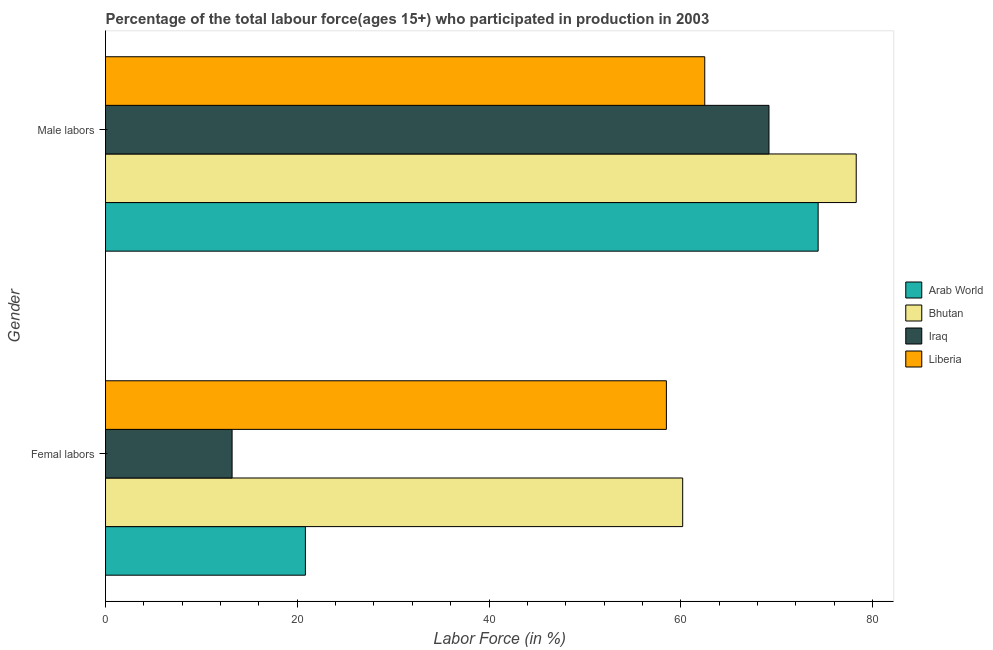How many bars are there on the 1st tick from the top?
Offer a very short reply. 4. What is the label of the 2nd group of bars from the top?
Your response must be concise. Femal labors. What is the percentage of male labour force in Bhutan?
Your response must be concise. 78.3. Across all countries, what is the maximum percentage of female labor force?
Make the answer very short. 60.2. Across all countries, what is the minimum percentage of male labour force?
Provide a succinct answer. 62.5. In which country was the percentage of male labour force maximum?
Provide a short and direct response. Bhutan. In which country was the percentage of male labour force minimum?
Your answer should be very brief. Liberia. What is the total percentage of male labour force in the graph?
Give a very brief answer. 284.33. What is the difference between the percentage of female labor force in Arab World and that in Bhutan?
Ensure brevity in your answer.  -39.35. What is the difference between the percentage of male labour force in Bhutan and the percentage of female labor force in Iraq?
Keep it short and to the point. 65.1. What is the average percentage of female labor force per country?
Your answer should be compact. 38.19. What is the difference between the percentage of female labor force and percentage of male labour force in Arab World?
Provide a succinct answer. -53.48. What is the ratio of the percentage of female labor force in Bhutan to that in Arab World?
Make the answer very short. 2.89. In how many countries, is the percentage of female labor force greater than the average percentage of female labor force taken over all countries?
Offer a very short reply. 2. What does the 2nd bar from the top in Male labors represents?
Your response must be concise. Iraq. What does the 3rd bar from the bottom in Male labors represents?
Your answer should be very brief. Iraq. How many bars are there?
Provide a succinct answer. 8. Are all the bars in the graph horizontal?
Your answer should be compact. Yes. How many countries are there in the graph?
Offer a very short reply. 4. What is the difference between two consecutive major ticks on the X-axis?
Provide a succinct answer. 20. Are the values on the major ticks of X-axis written in scientific E-notation?
Keep it short and to the point. No. Where does the legend appear in the graph?
Your answer should be very brief. Center right. How many legend labels are there?
Ensure brevity in your answer.  4. How are the legend labels stacked?
Make the answer very short. Vertical. What is the title of the graph?
Provide a short and direct response. Percentage of the total labour force(ages 15+) who participated in production in 2003. Does "Jordan" appear as one of the legend labels in the graph?
Offer a terse response. No. What is the label or title of the Y-axis?
Your answer should be very brief. Gender. What is the Labor Force (in %) of Arab World in Femal labors?
Provide a succinct answer. 20.85. What is the Labor Force (in %) in Bhutan in Femal labors?
Provide a succinct answer. 60.2. What is the Labor Force (in %) in Iraq in Femal labors?
Offer a terse response. 13.2. What is the Labor Force (in %) in Liberia in Femal labors?
Give a very brief answer. 58.5. What is the Labor Force (in %) of Arab World in Male labors?
Ensure brevity in your answer.  74.33. What is the Labor Force (in %) of Bhutan in Male labors?
Offer a terse response. 78.3. What is the Labor Force (in %) in Iraq in Male labors?
Provide a succinct answer. 69.2. What is the Labor Force (in %) in Liberia in Male labors?
Keep it short and to the point. 62.5. Across all Gender, what is the maximum Labor Force (in %) of Arab World?
Make the answer very short. 74.33. Across all Gender, what is the maximum Labor Force (in %) in Bhutan?
Your answer should be very brief. 78.3. Across all Gender, what is the maximum Labor Force (in %) of Iraq?
Ensure brevity in your answer.  69.2. Across all Gender, what is the maximum Labor Force (in %) of Liberia?
Your answer should be very brief. 62.5. Across all Gender, what is the minimum Labor Force (in %) in Arab World?
Give a very brief answer. 20.85. Across all Gender, what is the minimum Labor Force (in %) in Bhutan?
Make the answer very short. 60.2. Across all Gender, what is the minimum Labor Force (in %) in Iraq?
Your answer should be compact. 13.2. Across all Gender, what is the minimum Labor Force (in %) in Liberia?
Ensure brevity in your answer.  58.5. What is the total Labor Force (in %) in Arab World in the graph?
Provide a succinct answer. 95.17. What is the total Labor Force (in %) in Bhutan in the graph?
Provide a short and direct response. 138.5. What is the total Labor Force (in %) of Iraq in the graph?
Offer a very short reply. 82.4. What is the total Labor Force (in %) in Liberia in the graph?
Your answer should be compact. 121. What is the difference between the Labor Force (in %) of Arab World in Femal labors and that in Male labors?
Offer a terse response. -53.48. What is the difference between the Labor Force (in %) of Bhutan in Femal labors and that in Male labors?
Keep it short and to the point. -18.1. What is the difference between the Labor Force (in %) of Iraq in Femal labors and that in Male labors?
Your answer should be compact. -56. What is the difference between the Labor Force (in %) in Liberia in Femal labors and that in Male labors?
Offer a very short reply. -4. What is the difference between the Labor Force (in %) of Arab World in Femal labors and the Labor Force (in %) of Bhutan in Male labors?
Your response must be concise. -57.45. What is the difference between the Labor Force (in %) of Arab World in Femal labors and the Labor Force (in %) of Iraq in Male labors?
Your response must be concise. -48.35. What is the difference between the Labor Force (in %) in Arab World in Femal labors and the Labor Force (in %) in Liberia in Male labors?
Provide a short and direct response. -41.65. What is the difference between the Labor Force (in %) of Bhutan in Femal labors and the Labor Force (in %) of Iraq in Male labors?
Offer a very short reply. -9. What is the difference between the Labor Force (in %) of Iraq in Femal labors and the Labor Force (in %) of Liberia in Male labors?
Your answer should be very brief. -49.3. What is the average Labor Force (in %) of Arab World per Gender?
Your response must be concise. 47.59. What is the average Labor Force (in %) in Bhutan per Gender?
Make the answer very short. 69.25. What is the average Labor Force (in %) in Iraq per Gender?
Make the answer very short. 41.2. What is the average Labor Force (in %) of Liberia per Gender?
Provide a short and direct response. 60.5. What is the difference between the Labor Force (in %) of Arab World and Labor Force (in %) of Bhutan in Femal labors?
Ensure brevity in your answer.  -39.35. What is the difference between the Labor Force (in %) of Arab World and Labor Force (in %) of Iraq in Femal labors?
Offer a terse response. 7.65. What is the difference between the Labor Force (in %) of Arab World and Labor Force (in %) of Liberia in Femal labors?
Ensure brevity in your answer.  -37.65. What is the difference between the Labor Force (in %) in Bhutan and Labor Force (in %) in Iraq in Femal labors?
Provide a succinct answer. 47. What is the difference between the Labor Force (in %) in Bhutan and Labor Force (in %) in Liberia in Femal labors?
Offer a very short reply. 1.7. What is the difference between the Labor Force (in %) of Iraq and Labor Force (in %) of Liberia in Femal labors?
Give a very brief answer. -45.3. What is the difference between the Labor Force (in %) in Arab World and Labor Force (in %) in Bhutan in Male labors?
Your answer should be compact. -3.97. What is the difference between the Labor Force (in %) in Arab World and Labor Force (in %) in Iraq in Male labors?
Offer a terse response. 5.13. What is the difference between the Labor Force (in %) of Arab World and Labor Force (in %) of Liberia in Male labors?
Offer a very short reply. 11.83. What is the difference between the Labor Force (in %) of Bhutan and Labor Force (in %) of Liberia in Male labors?
Give a very brief answer. 15.8. What is the difference between the Labor Force (in %) in Iraq and Labor Force (in %) in Liberia in Male labors?
Make the answer very short. 6.7. What is the ratio of the Labor Force (in %) in Arab World in Femal labors to that in Male labors?
Offer a very short reply. 0.28. What is the ratio of the Labor Force (in %) of Bhutan in Femal labors to that in Male labors?
Your response must be concise. 0.77. What is the ratio of the Labor Force (in %) of Iraq in Femal labors to that in Male labors?
Provide a short and direct response. 0.19. What is the ratio of the Labor Force (in %) in Liberia in Femal labors to that in Male labors?
Your response must be concise. 0.94. What is the difference between the highest and the second highest Labor Force (in %) in Arab World?
Keep it short and to the point. 53.48. What is the difference between the highest and the second highest Labor Force (in %) of Liberia?
Offer a very short reply. 4. What is the difference between the highest and the lowest Labor Force (in %) in Arab World?
Make the answer very short. 53.48. What is the difference between the highest and the lowest Labor Force (in %) of Liberia?
Your response must be concise. 4. 